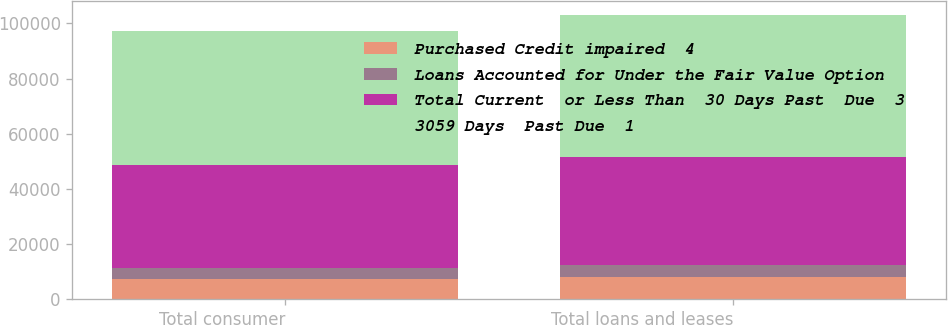<chart> <loc_0><loc_0><loc_500><loc_500><stacked_bar_chart><ecel><fcel>Total consumer<fcel>Total loans and leases<nl><fcel>Purchased Credit impaired  4<fcel>7545<fcel>8134<nl><fcel>Loans Accounted for Under the Fair Value Option<fcel>3948<fcel>4379<nl><fcel>Total Current  or Less Than  30 Days Past  Due  3<fcel>37216<fcel>39036<nl><fcel>3059 Days  Past Due  1<fcel>48709<fcel>51549<nl></chart> 